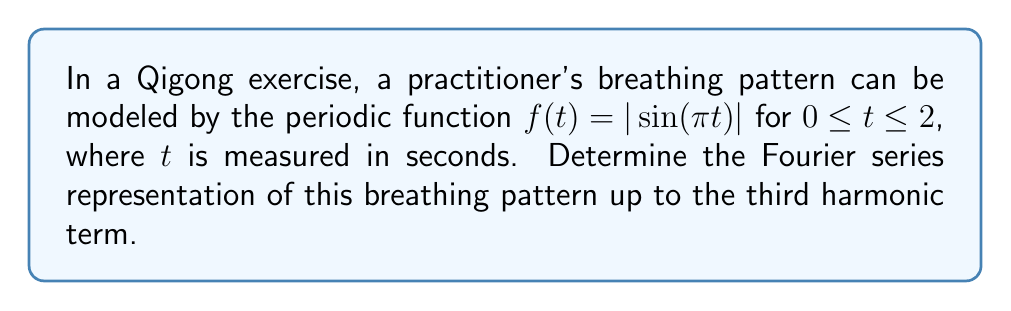Help me with this question. To find the Fourier series representation, we'll follow these steps:

1) The general form of a Fourier series is:

   $f(t) = \frac{a_0}{2} + \sum_{n=1}^{\infty} [a_n \cos(n\omega t) + b_n \sin(n\omega t)]$

   where $\omega = \frac{2\pi}{T}$, and $T$ is the period.

2) For our function, the period $T = 2$, so $\omega = \pi$.

3) We need to calculate $a_0$, $a_n$, and $b_n$:

   $a_0 = \frac{2}{T} \int_0^T f(t) dt$
   $a_n = \frac{2}{T} \int_0^T f(t) \cos(n\omega t) dt$
   $b_n = \frac{2}{T} \int_0^T f(t) \sin(n\omega t) dt$

4) Calculating $a_0$:
   
   $a_0 = \frac{2}{2} \int_0^2 |\sin(\pi t)| dt = 2 \int_0^1 \sin(\pi t) dt = \frac{4}{\pi}$

5) For $a_n$:
   
   $a_n = \frac{2}{2} \int_0^2 |\sin(\pi t)| \cos(n\pi t) dt$
   
   This integral is zero for odd $n$ due to symmetry.
   For even $n$, $a_n = \frac{4}{\pi(4n^2-1)}$

6) For $b_n$:
   
   $b_n = \frac{2}{2} \int_0^2 |\sin(\pi t)| \sin(n\pi t) dt$
   
   This integral is zero for all $n$ due to the odd symmetry of the integrand about $t=1$.

7) Therefore, up to the third harmonic, our Fourier series is:

   $f(t) = \frac{2}{\pi} + \frac{4}{3\pi} \cos(2\pi t) + \frac{4}{15\pi} \cos(4\pi t) + \frac{4}{35\pi} \cos(6\pi t)$
Answer: $f(t) = \frac{2}{\pi} + \frac{4}{3\pi} \cos(2\pi t) + \frac{4}{15\pi} \cos(4\pi t) + \frac{4}{35\pi} \cos(6\pi t)$ 